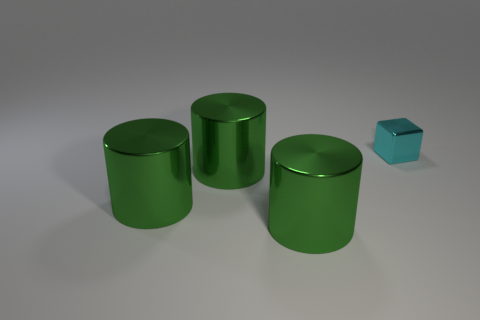What is the shape of the cyan shiny object?
Your response must be concise. Cube. How many cyan cubes have the same material as the small cyan thing?
Your response must be concise. 0. Are there fewer small blue cylinders than small things?
Keep it short and to the point. Yes. Is the number of cubes in front of the cyan metallic object less than the number of tiny cyan metallic cubes?
Your answer should be very brief. Yes. How many matte things are big green cylinders or red things?
Make the answer very short. 0. Is there anything else that is the same size as the cyan metallic block?
Offer a terse response. No. What size is the cube?
Offer a very short reply. Small. How many big things are metal blocks or green objects?
Make the answer very short. 3. Is there anything else that has the same shape as the tiny cyan thing?
Your response must be concise. No. How many big matte blocks are there?
Provide a succinct answer. 0. 